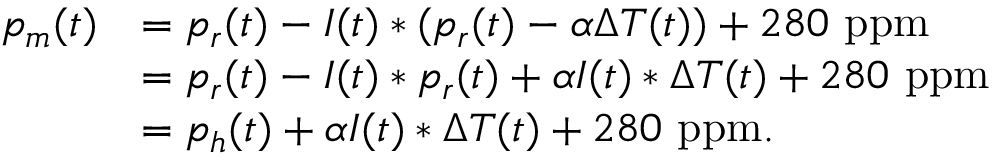<formula> <loc_0><loc_0><loc_500><loc_500>\begin{array} { r l } { p _ { m } ( t ) } & { = p _ { r } ( t ) - I ( t ) \ast ( p _ { r } ( t ) - \alpha \Delta T ( t ) ) + 2 8 0 p p m } \\ & { = p _ { r } ( t ) - I ( t ) \ast p _ { r } ( t ) + \alpha I ( t ) \ast \Delta T ( t ) + 2 8 0 p p m } \\ & { = p _ { h } ( t ) + \alpha I ( t ) \ast \Delta T ( t ) + 2 8 0 p p m . } \end{array}</formula> 